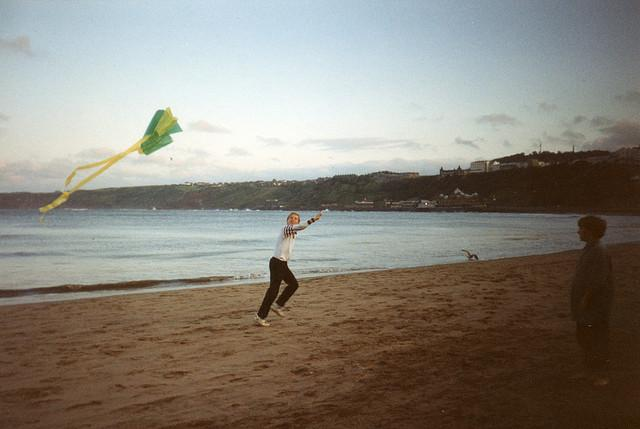Where is the kite in relation to the boy? Please explain your reasoning. behind. The kite is flying from behind. 